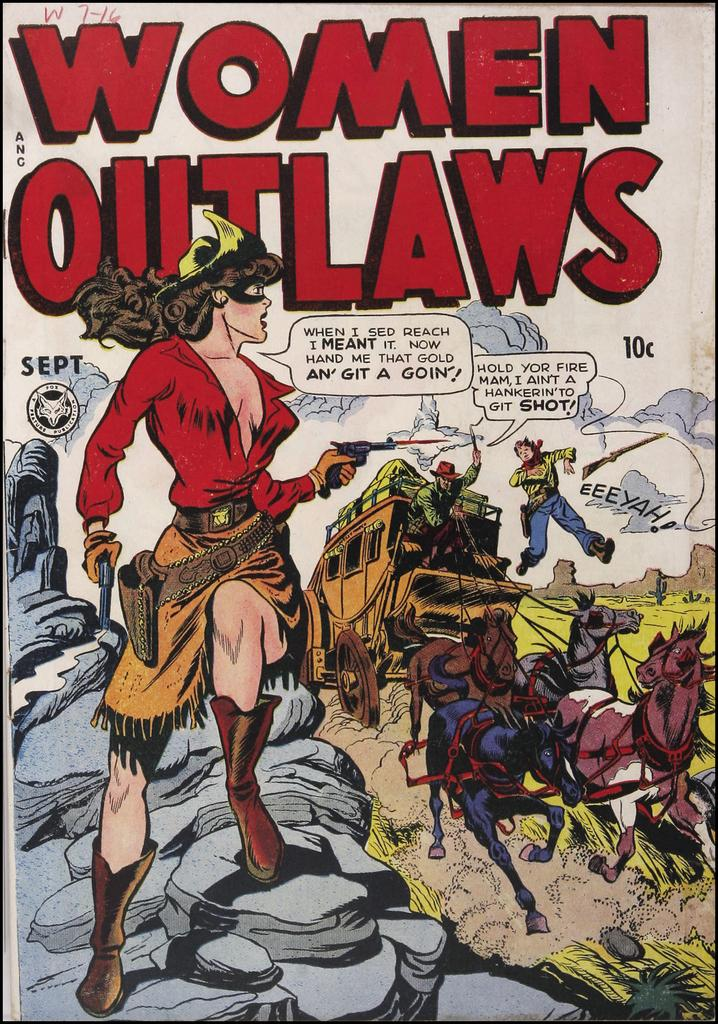Who or what can be seen in the image? There are persons, vehicles, and horses in the image. What else is present in the image besides the persons, vehicles, and horses? There is text in the image. What type of discussion is taking place between the chicken and the hospital in the image? There is no chicken or hospital present in the image, so there cannot be a discussion between them. 